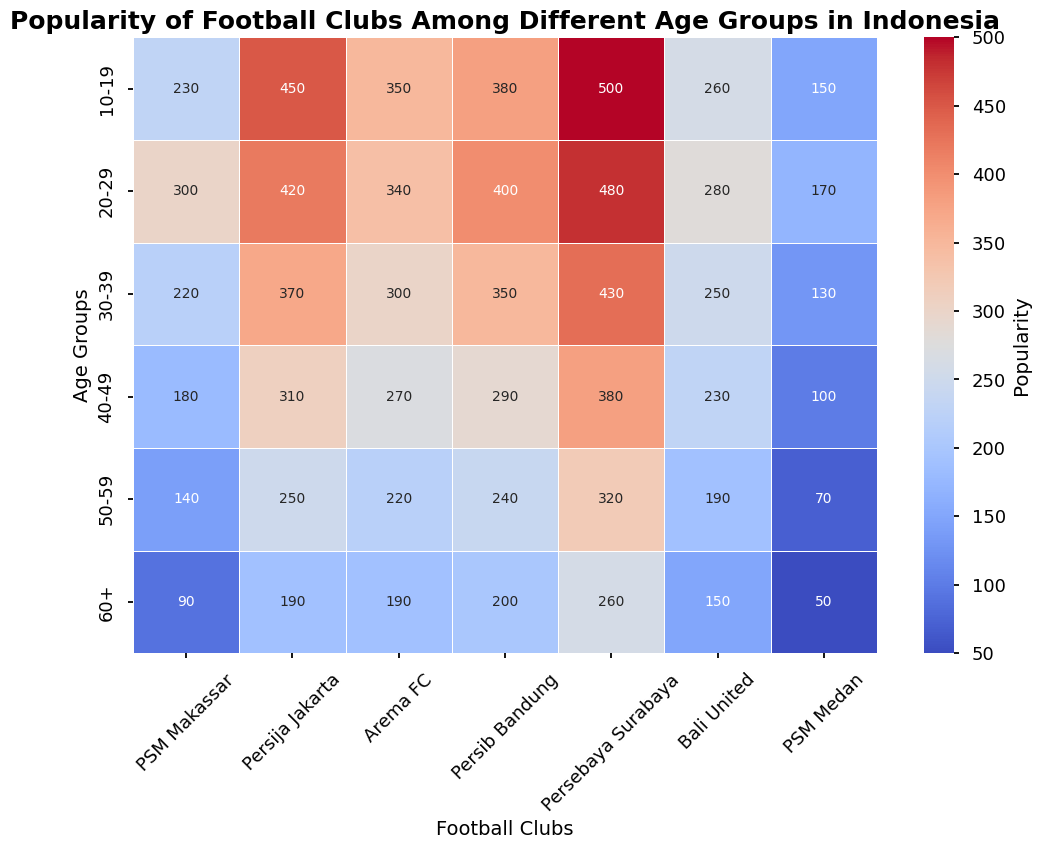What is the most popular football club among the age group 10-19? Look for the highest number in the row corresponding to the 10-19 age group. It shows 500 under Persebaya Surabaya.
Answer: Persebaya Surabaya Which age group shows the least popularity for PSM Makassar? Look for the smallest number in the PSM Makassar column. The smallest value is 90 in the 60+ age group.
Answer: 60+ How does the popularity of Persija Jakarta among the 20-29 age group compare to the 30-39 age group? Compare the values in the Persija Jakarta column for the 20-29 and 30-39 age groups. The values are 420 and 370, respectively.
Answer: 20-29 is more popular Which football club has the least popularity among the 30-39 age group? Look for the smallest number in the 30-39 age group row. The smallest value is 130 under PSM Medan.
Answer: PSM Medan How does the overall popularity of Arema FC across all age groups compare with Persib Bandung? Sum the values of Arema FC and Persib Bandung across all age groups and compare. Arema FC: 350+340+300+270+220+190 = 1670, Persib Bandung: 380+400+350+290+240+200 = 1860.
Answer: Persib Bandung is more popular Find the average popularity of PSM Medan across all age groups. Sum the values of PSM Medan across all age groups and divide by the number of age groups. The values are 150+170+130+100+70+50 = 670. Divide by 6 (number of age groups): 670/6 ≈ 111.67
Answer: 111.67 What is the difference in popularity between Bali United and Persebaya Surabaya for the 40-49 age group? Subtract the value of Bali United from Persebaya Surabaya for the 40-49 age group. The values are 380 (Persebaya Surabaya) and 230 (Bali United). 380 - 230 = 150
Answer: 150 Which football club has the most consistent popularity across all age groups? Calculate the variance of popularity for each football club and compare. Lower variance indicates more consistency. From a quick overview, Persija Jakarta shows small changes: 450, 420, 370, 310, 250, 190.
Answer: Persija Jakarta In the 50-59 age group, what is the visual color difference between Persib Bandung and Persebaya Surabaya? Observe the heatmap colors for the 50-59 age group. Persib Bandung shows a color closer to mid-range, while Persebaya Surabaya shows a more intense (probably warmer) color.
Answer: Persebaya Surabaya is more intense What age group shows the most balanced popularity among all football clubs? Look for the age group where the values across clubs are closest together without large variations. Evaluate each row: the 60+ age group ranges from 90 to 260, showing relatively balanced lower values across all clubs.
Answer: 60+ 